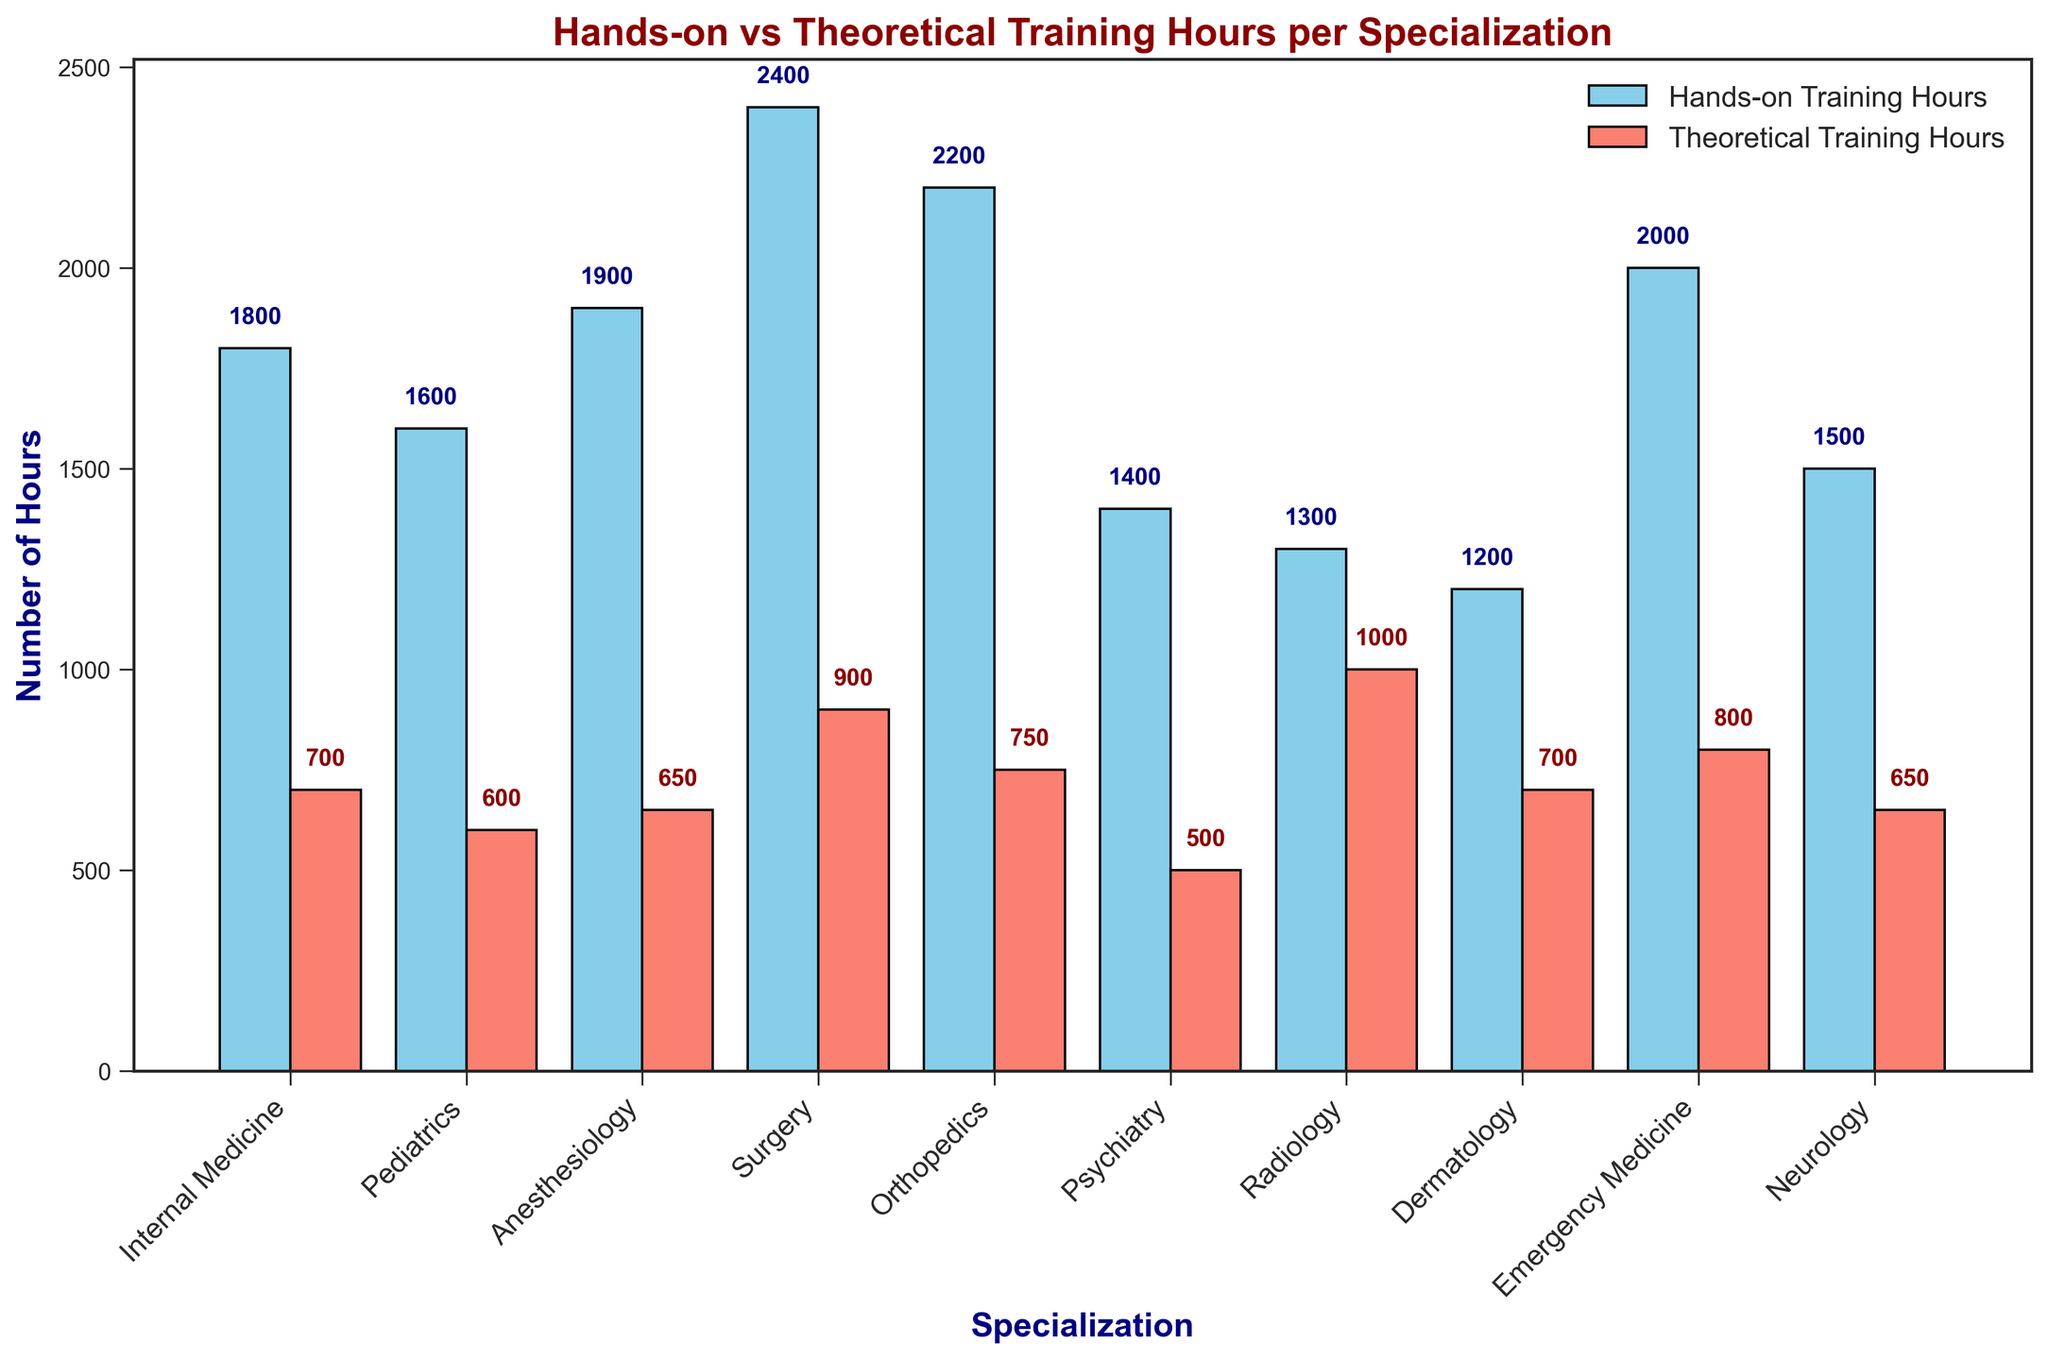Which specialization has the highest number of hands-on training hours? From the bar chart, observe that the bar representing Surgery has the highest height among all the specializations for hands-on training hours.
Answer: Surgery Which specialization has the least number of theoretical training hours? The bar representing Psychiatry is the shortest among all the specializations for theoretical training hours.
Answer: Psychiatry How many more hours of hands-on training does Emergency Medicine have compared to Dermatology? The hands-on training hours for Emergency Medicine is 2000 hours and for Dermatology is 1200 hours. Subtracting these gives 2000 - 1200 = 800 hours.
Answer: 800 What is the average number of theoretical training hours across all specializations? Sum the theoretical training hours for all specializations (700 + 600 + 650 + 900 + 750 + 500 + 1000 + 700 + 800 + 650 = 7250) and divide by the number of specializations (10). The average is 7250 / 10 = 725 hours.
Answer: 725 Which specialization has the most balanced (least difference) hours between hands-on and theoretical training? Calculate the absolute difference for each specialization and find the smallest value. Psychiatry has (1400 - 500 = 900), less than any other specialization.
Answer: Psychiatry What is the combined total number of training hours (hands-on and theoretical) for Radiology? Add the hands-on and theoretical training hours for Radiology: 1300 + 1000 = 2300 hours.
Answer: 2300 Between Anesthesiology and Neurology, which specialization has more hands-on training hours? From the bar chart, Anesthesiology has 1900 hands-on training hours while Neurology has 1500. Therefore, Anesthesiology has more.
Answer: Anesthesiology What is the total difference in theoretical training hours between Radiology and Internal Medicine? Theoretical training hours for Radiology is 1000 and for Internal Medicine is 700. The difference is 1000 - 700 = 300 hours.
Answer: 300 Which specialization has the greatest discrepancy between hands-on and theoretical training hours? Calculate the differences for each specialization and find the largest value. Surgery has 2400 - 900 = 1500, which is the largest discrepancy.
Answer: Surgery What is the ratio of hands-on to theoretical training hours in Orthopedics? The hands-on training hours for Orthopedics is 2200 and the theoretical training hours is 750. The ratio is 2200 / 750 = 2.93 (approximately).
Answer: 2.93 